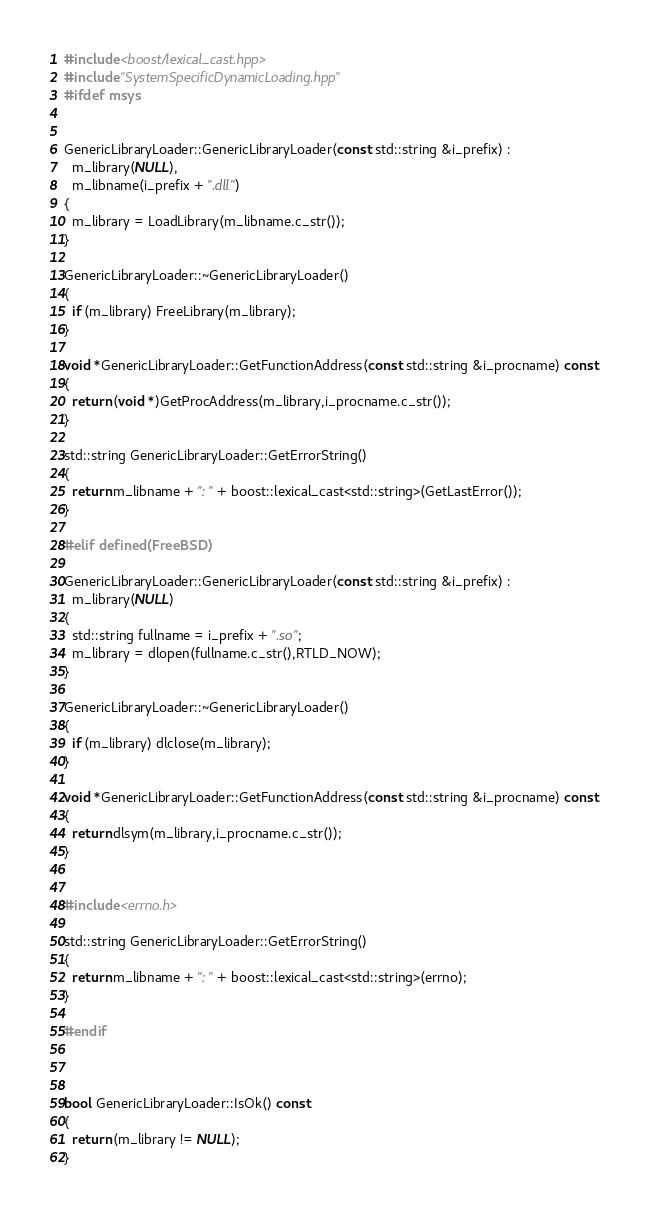Convert code to text. <code><loc_0><loc_0><loc_500><loc_500><_C++_>#include <boost/lexical_cast.hpp>
#include "SystemSpecificDynamicLoading.hpp"
#ifdef msys


GenericLibraryLoader::GenericLibraryLoader(const std::string &i_prefix) :
  m_library(NULL),
  m_libname(i_prefix + ".dll")
{
  m_library = LoadLibrary(m_libname.c_str());
}

GenericLibraryLoader::~GenericLibraryLoader()
{
  if (m_library) FreeLibrary(m_library);
}

void *GenericLibraryLoader::GetFunctionAddress(const std::string &i_procname) const
{
  return (void *)GetProcAddress(m_library,i_procname.c_str());
}

std::string GenericLibraryLoader::GetErrorString()
{
  return m_libname + ": " + boost::lexical_cast<std::string>(GetLastError());
}

#elif defined(FreeBSD)

GenericLibraryLoader::GenericLibraryLoader(const std::string &i_prefix) :
  m_library(NULL)
{
  std::string fullname = i_prefix + ".so";
  m_library = dlopen(fullname.c_str(),RTLD_NOW);
}

GenericLibraryLoader::~GenericLibraryLoader()
{
  if (m_library) dlclose(m_library);
}

void *GenericLibraryLoader::GetFunctionAddress(const std::string &i_procname) const
{
  return dlsym(m_library,i_procname.c_str());
}


#include <errno.h>

std::string GenericLibraryLoader::GetErrorString()
{
  return m_libname + ": " + boost::lexical_cast<std::string>(errno);
}

#endif



bool GenericLibraryLoader::IsOk() const
{
  return (m_library != NULL);
}
</code> 